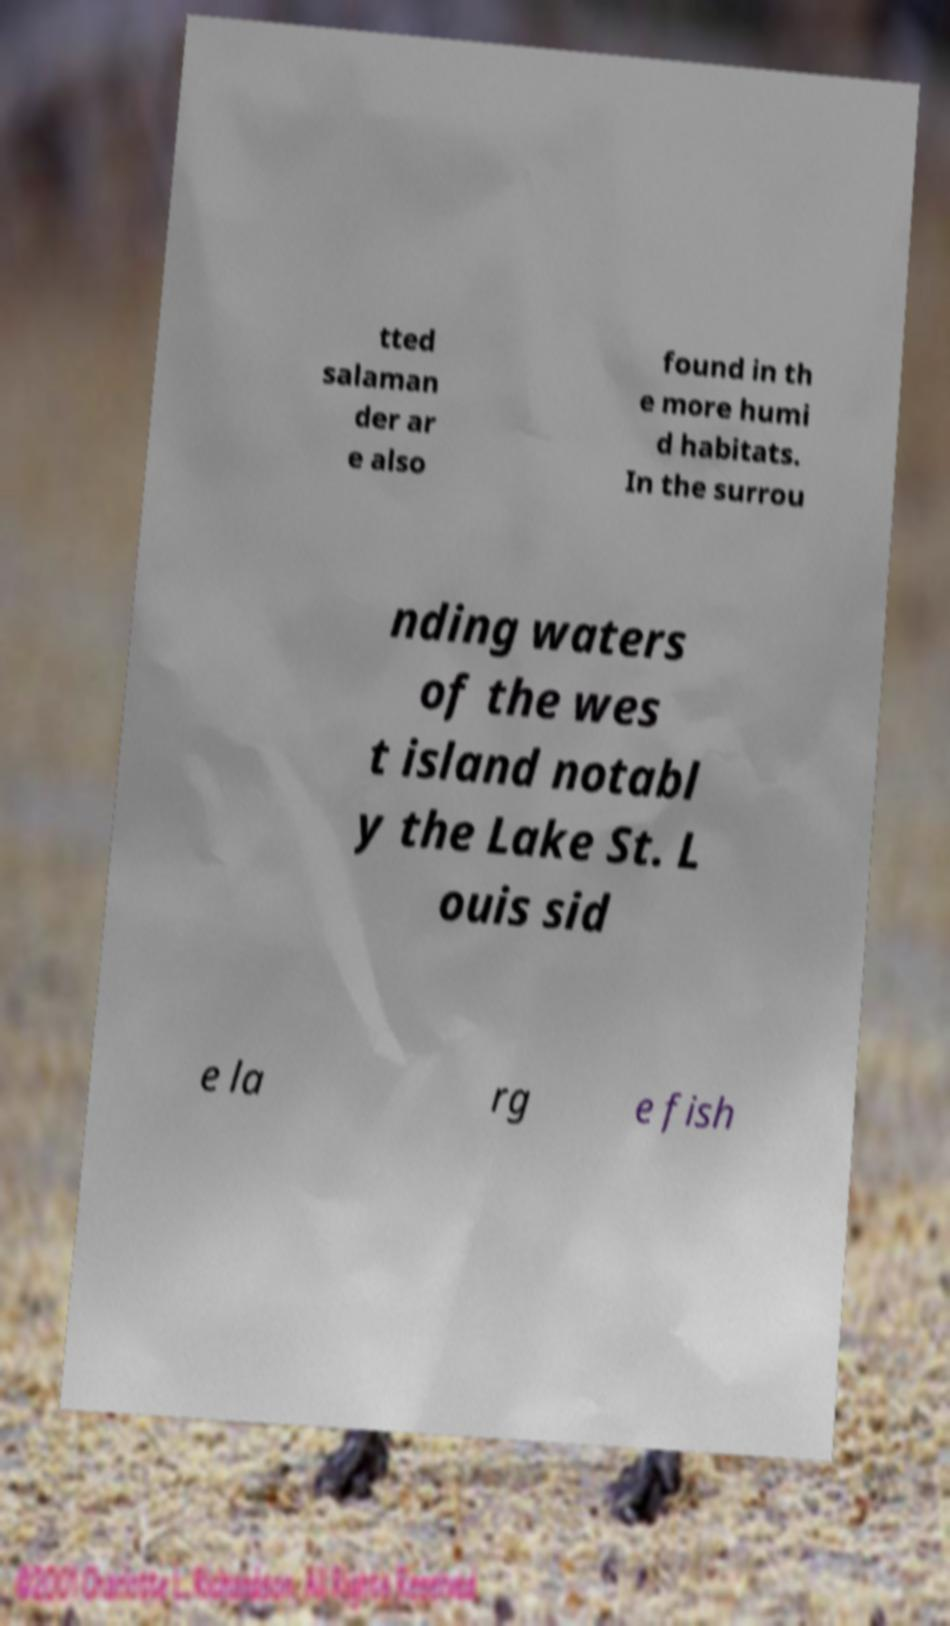What messages or text are displayed in this image? I need them in a readable, typed format. tted salaman der ar e also found in th e more humi d habitats. In the surrou nding waters of the wes t island notabl y the Lake St. L ouis sid e la rg e fish 